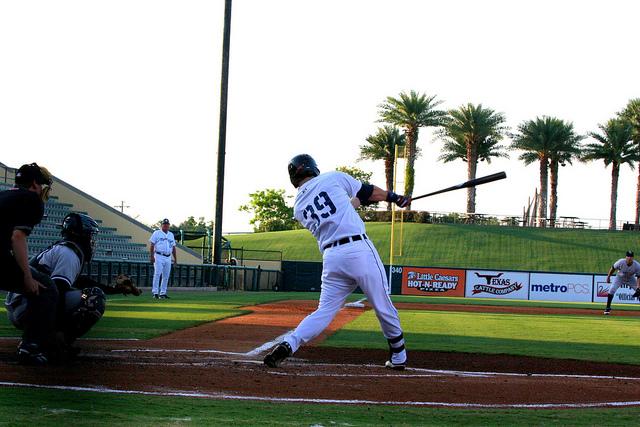What number is on the batter's shirt?
Keep it brief. 39. What is the man doing?
Concise answer only. Batting. What sport is this?
Write a very short answer. Baseball. What number is the batter?
Short answer required. 39. What pizza is advertised?
Short answer required. Little caesar's. Is this person trying to hit a basketball?
Quick response, please. No. How many shirts hanging?
Short answer required. 0. What is he catching?
Be succinct. Baseball. Is this a professional game?
Be succinct. No. What number is on his back?
Give a very brief answer. 39. Is this in a stadium?
Short answer required. Yes. What is the man holding?
Concise answer only. Bat. Are there people in the bleachers?
Keep it brief. No. What number is on this player's jersey?
Keep it brief. 39. How many people are sitting on the benches?
Short answer required. 0. 